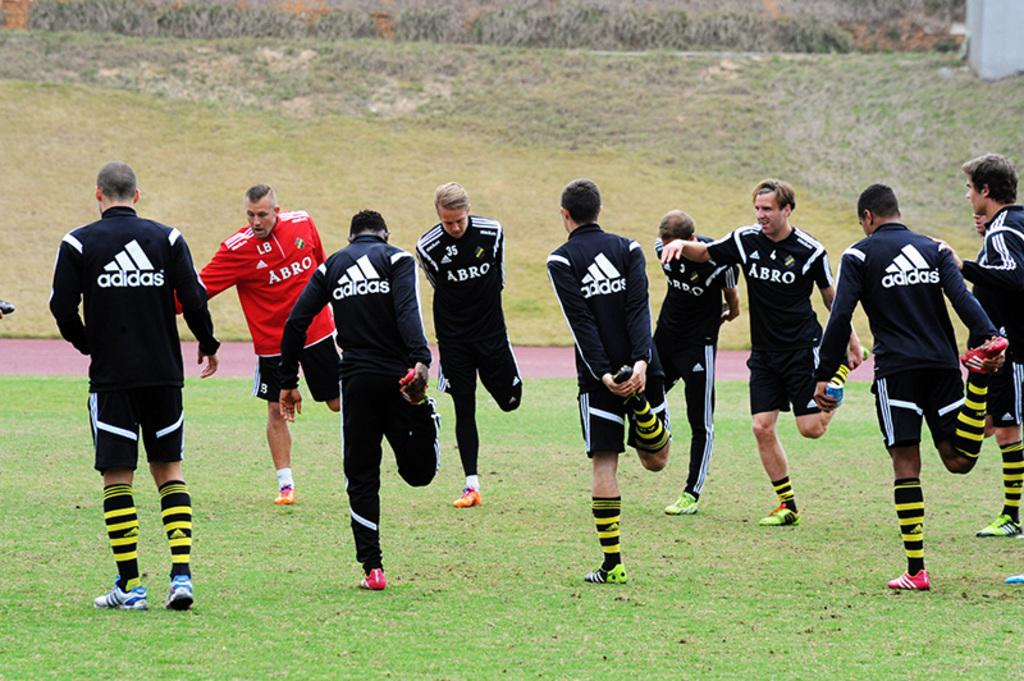<image>
Give a short and clear explanation of the subsequent image. Men wearing Adidas warmups are stretching out on a field. 